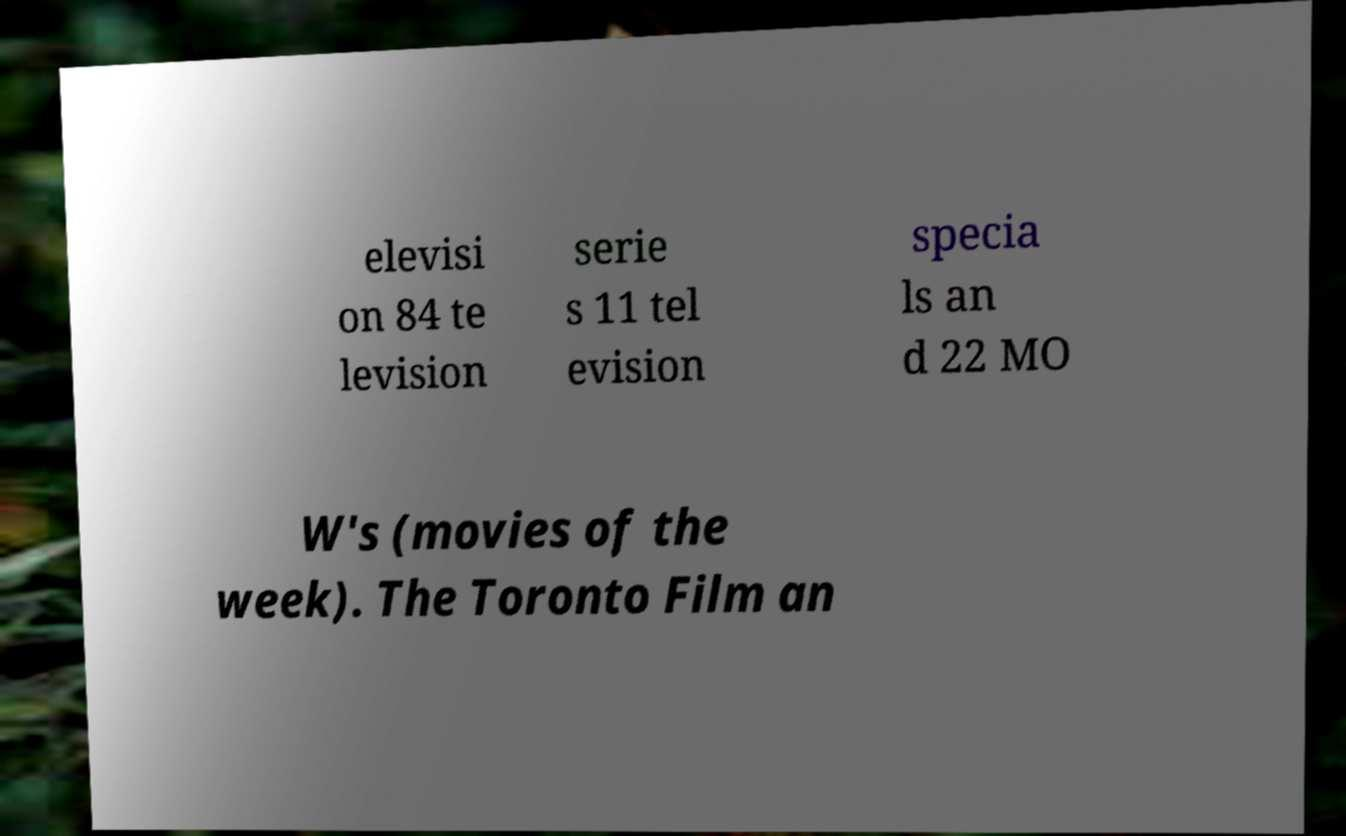Please identify and transcribe the text found in this image. elevisi on 84 te levision serie s 11 tel evision specia ls an d 22 MO W's (movies of the week). The Toronto Film an 